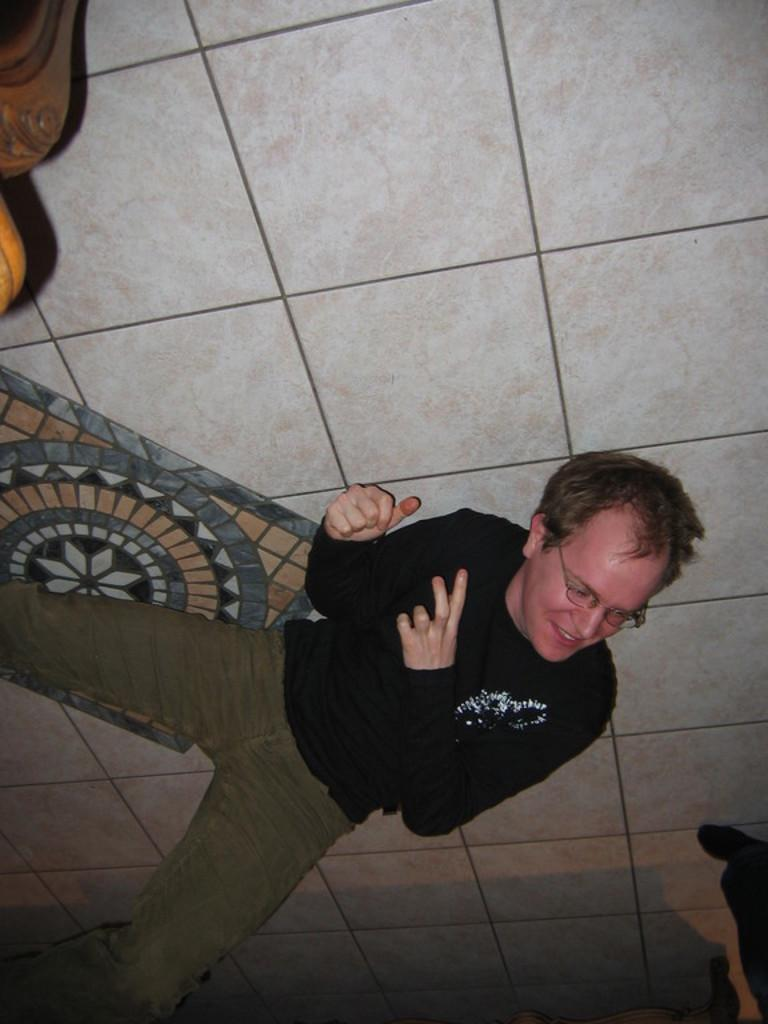What is the position of the person in the image? There is a person lying on the floor in the image. Can you describe the object in the top left corner of the image? Unfortunately, the provided facts do not give any information about the object in the top left corner of the image. Is there any smoke coming from the person lying on the floor in the image? There is no smoke present in the image, as it only features a person lying on the floor and an unidentified object in the top left corner. 